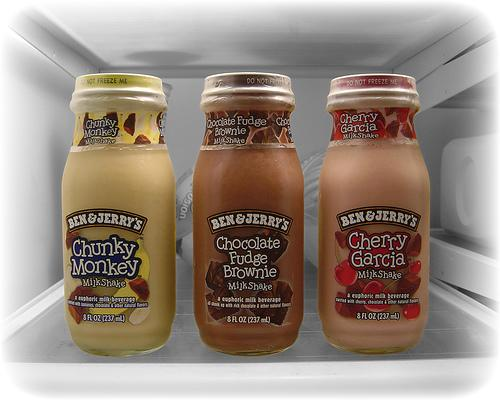Count the total number of milkshake bottles in the image. There are three milkshake bottles in the image. What type of container are the milkshakes kept in? The milkshakes are inside a white cooler. Describe the labels on the milkshake bottles. The labels have the Ben & Jerry's logo, the milkshake flavors, images of the ingredients, and the container sizes in ounces. What are the sizes of the milkshake servings mentioned on the labels? Each label displays a serving size of 8 ounces. What objects are depicted on the labels of the milkshake bottles? The objects are images of a banana, a cherry, and brownies. Describe the arrangement of the milkshakes and the shelf that they are on. The three milkshakes are placed next to each other on a refrigerator shelf. Identify the type of drinks in the image. There are three bottles of flavored milkshakes in the image. What is the brand of the milkshakes and where is it visible? The brand is Ben & Jerry's, and it's visible on the labels of the bottles. Report the material of the milkshake containers and what they hold. The milkshakes are in glass bottles containing 237 mL of flavored milk. What are the flavors of the milkshakes? The flavors are Chunky Monkey, Chocolate Fudge Brownie, and Cherry Garcia. 